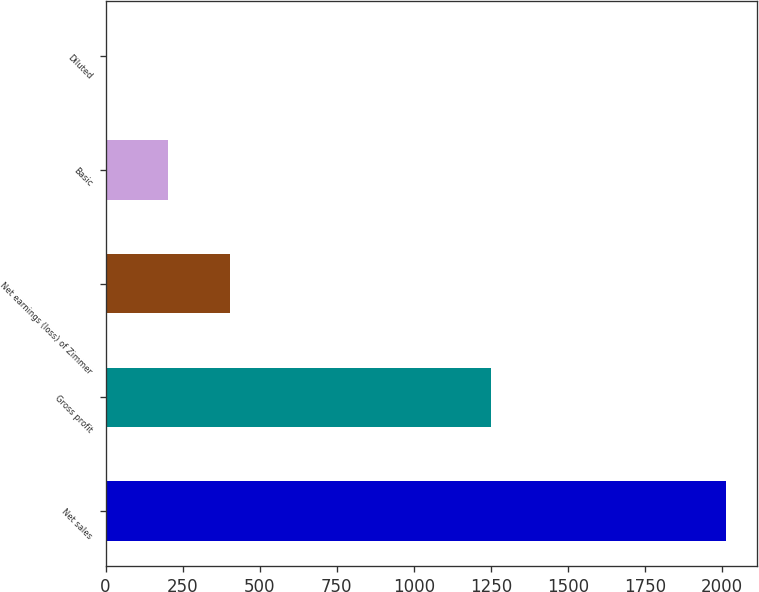<chart> <loc_0><loc_0><loc_500><loc_500><bar_chart><fcel>Net sales<fcel>Gross profit<fcel>Net earnings (loss) of Zimmer<fcel>Basic<fcel>Diluted<nl><fcel>2013.1<fcel>1250.1<fcel>402.9<fcel>201.62<fcel>0.34<nl></chart> 